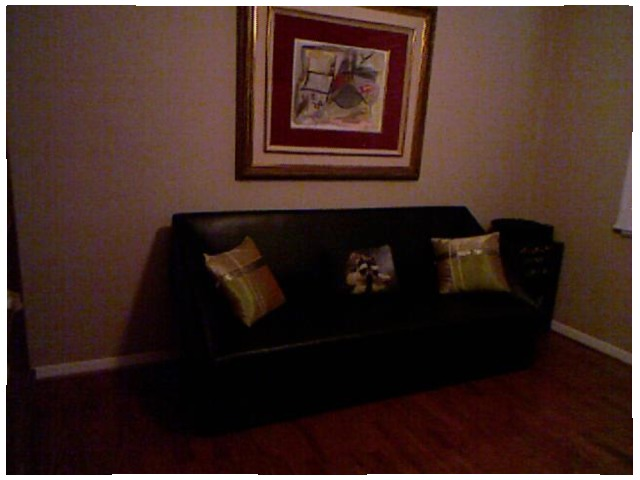<image>
Is the pillow in front of the pillow? No. The pillow is not in front of the pillow. The spatial positioning shows a different relationship between these objects. Is the golden pillow on the sofa? Yes. Looking at the image, I can see the golden pillow is positioned on top of the sofa, with the sofa providing support. Is the chair above the land? No. The chair is not positioned above the land. The vertical arrangement shows a different relationship. 